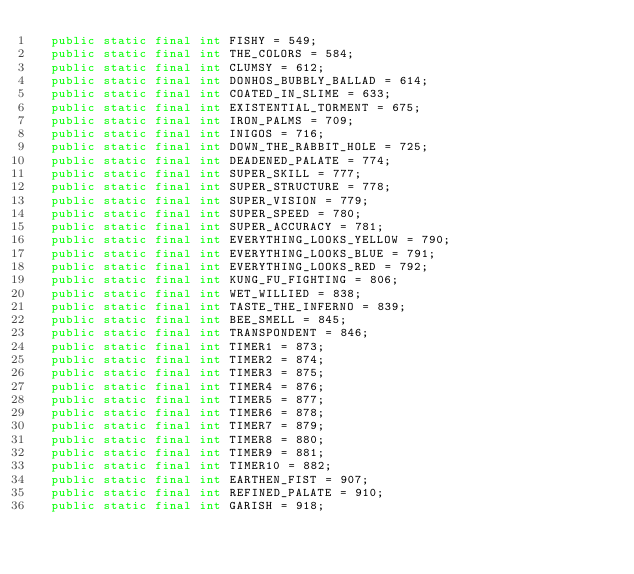Convert code to text. <code><loc_0><loc_0><loc_500><loc_500><_Java_>  public static final int FISHY = 549;
  public static final int THE_COLORS = 584;
  public static final int CLUMSY = 612;
  public static final int DONHOS_BUBBLY_BALLAD = 614;
  public static final int COATED_IN_SLIME = 633;
  public static final int EXISTENTIAL_TORMENT = 675;
  public static final int IRON_PALMS = 709;
  public static final int INIGOS = 716;
  public static final int DOWN_THE_RABBIT_HOLE = 725;
  public static final int DEADENED_PALATE = 774;
  public static final int SUPER_SKILL = 777;
  public static final int SUPER_STRUCTURE = 778;
  public static final int SUPER_VISION = 779;
  public static final int SUPER_SPEED = 780;
  public static final int SUPER_ACCURACY = 781;
  public static final int EVERYTHING_LOOKS_YELLOW = 790;
  public static final int EVERYTHING_LOOKS_BLUE = 791;
  public static final int EVERYTHING_LOOKS_RED = 792;
  public static final int KUNG_FU_FIGHTING = 806;
  public static final int WET_WILLIED = 838;
  public static final int TASTE_THE_INFERNO = 839;
  public static final int BEE_SMELL = 845;
  public static final int TRANSPONDENT = 846;
  public static final int TIMER1 = 873;
  public static final int TIMER2 = 874;
  public static final int TIMER3 = 875;
  public static final int TIMER4 = 876;
  public static final int TIMER5 = 877;
  public static final int TIMER6 = 878;
  public static final int TIMER7 = 879;
  public static final int TIMER8 = 880;
  public static final int TIMER9 = 881;
  public static final int TIMER10 = 882;
  public static final int EARTHEN_FIST = 907;
  public static final int REFINED_PALATE = 910;
  public static final int GARISH = 918;</code> 